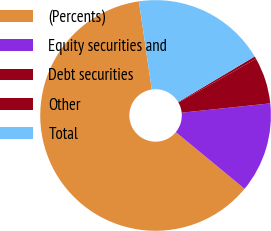<chart> <loc_0><loc_0><loc_500><loc_500><pie_chart><fcel>(Percents)<fcel>Equity securities and<fcel>Debt securities<fcel>Other<fcel>Total<nl><fcel>61.72%<fcel>12.64%<fcel>6.5%<fcel>0.37%<fcel>18.77%<nl></chart> 